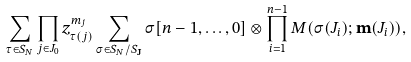<formula> <loc_0><loc_0><loc_500><loc_500>\sum _ { \tau \in S _ { N } } \prod _ { j \in J _ { 0 } } z _ { \tau ( j ) } ^ { m _ { j } } \sum _ { \sigma \in S _ { N } / S _ { \mathbf J } } \sigma [ n - 1 , \dots , 0 ] \otimes \prod _ { i = 1 } ^ { n - 1 } M ( \sigma ( J _ { i } ) ; \mathbf m ( J _ { i } ) ) ,</formula> 